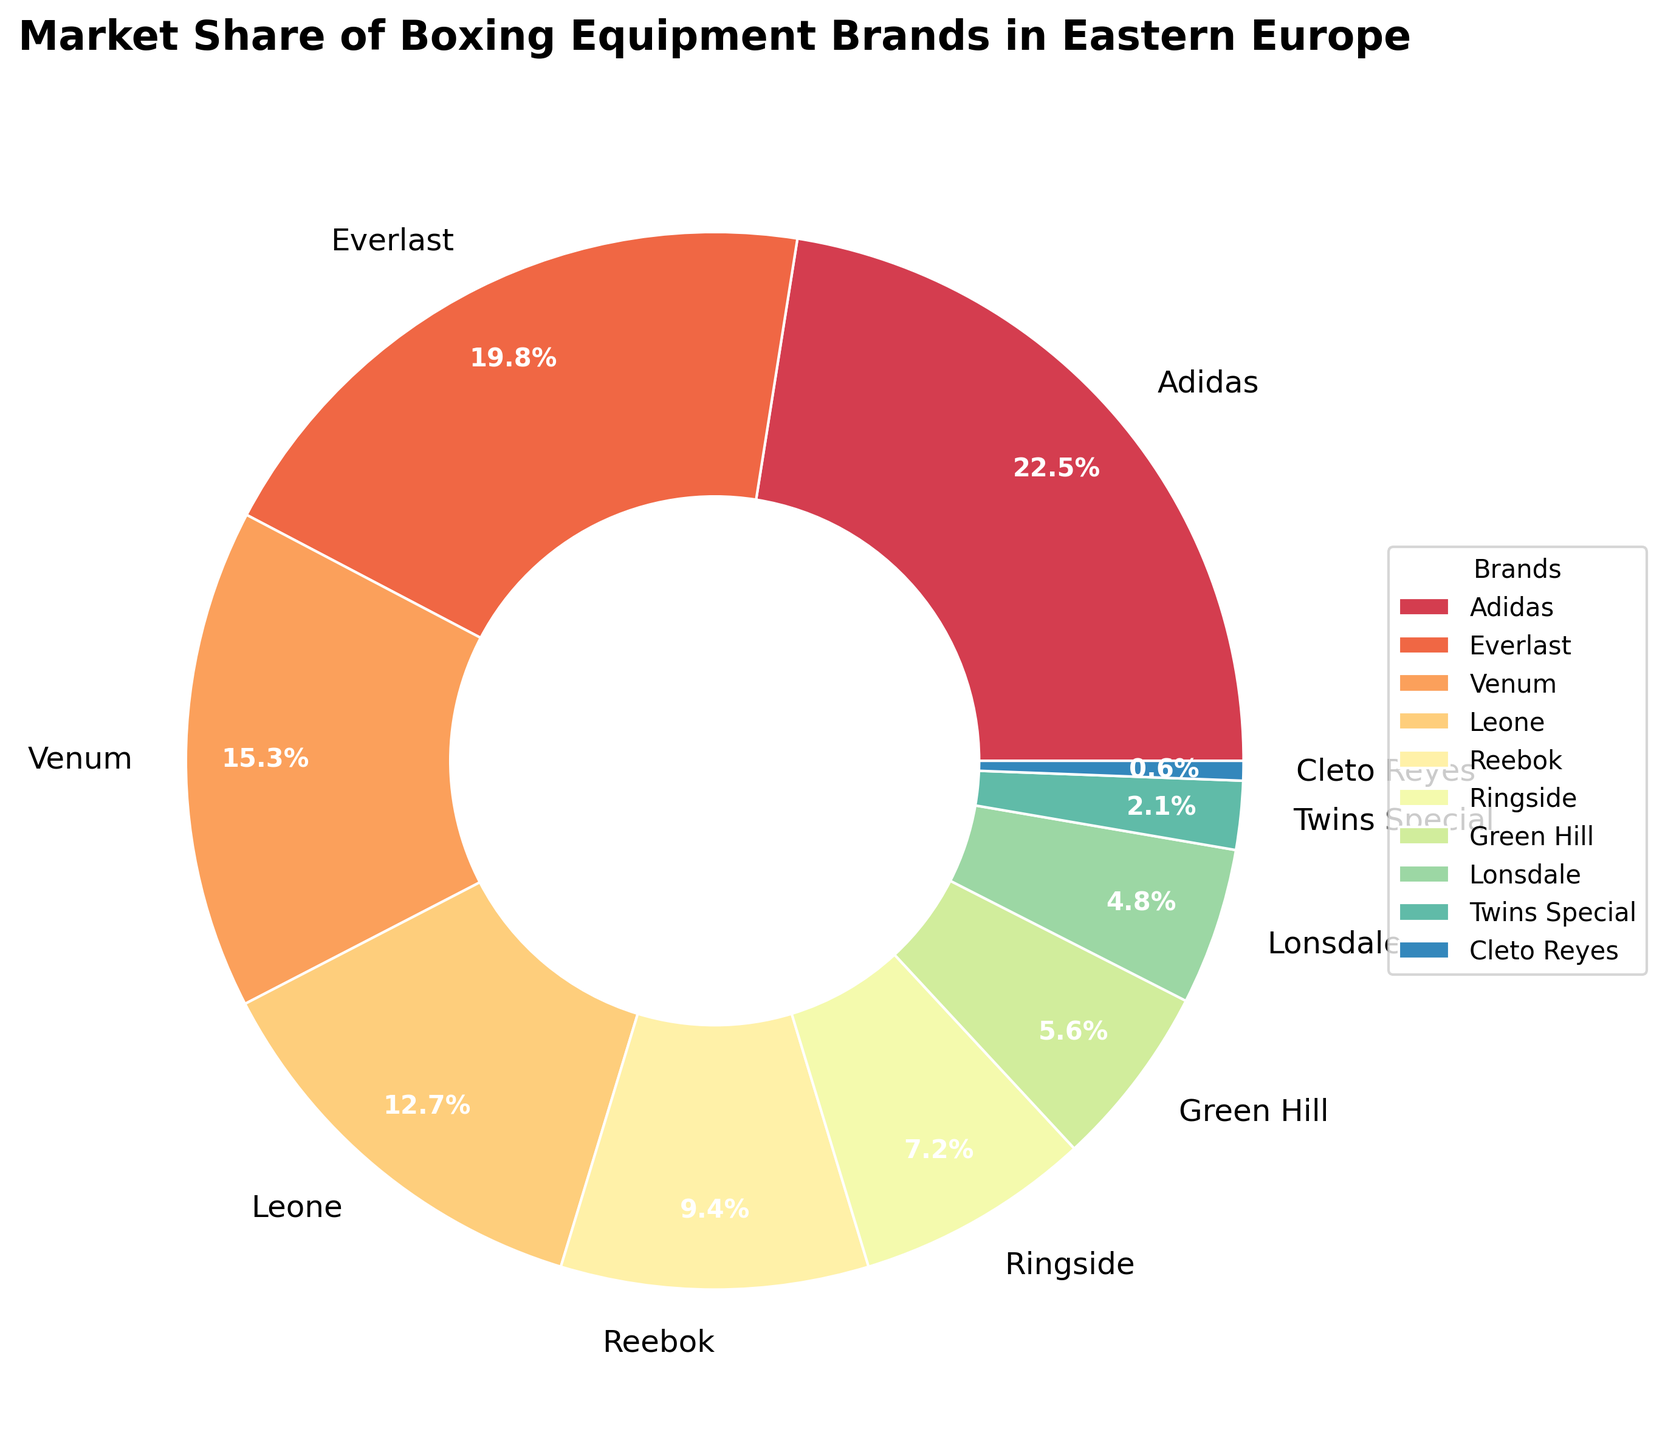Which brand has the highest market share? Adidas has the highest value at 22.5%. This can be identified visually as it occupies the largest portion of the pie chart.
Answer: Adidas What is the combined market share of the top three brands? The top three brands are Adidas (22.5%), Everlast (19.8%), and Venum (15.3%). Adding these together: 22.5 + 19.8 + 15.3 = 57.6%.
Answer: 57.6% How much more market share does Adidas have compared to Everlast? Adidas has a market share of 22.5%, whereas Everlast has 19.8%. Subtracting Everlast's share from Adidas's share: 22.5 - 19.8 = 2.7%.
Answer: 2.7% Which brands have a market share of less than 5%? The brands with less than 5% market share are Lonsdale (4.8%), Twins Special (2.1%), and Cleto Reyes (0.6%). This can be identified by observing the smaller sections of the pie chart and checking their labels.
Answer: Lonsdale, Twins Special, Cleto Reyes What percentage of the market is held by Leone and Reebok combined? Leone has a market share of 12.7% and Reebok has 9.4%. Adding these together: 12.7 + 9.4 = 22.1%.
Answer: 22.1% Which brand occupies the smallest portion of the pie chart? Cleto Reyes occupies the smallest portion with a market share of 0.6%. This can be identified by finding the smallest segment visually.
Answer: Cleto Reyes Is the market share of Venum greater than the combined market share of Ringside and Green Hill? Venum has 15.3%. Ringside has 7.2% and Green Hill has 5.6%, and their combined share is 7.2 + 5.6 = 12.8%. Since 15.3% is greater than 12.8%, Venum's share is greater.
Answer: Yes If Lonsdale's market share doubled, would it surpass Reebok's market share? Lonsdale's market share is 4.8%. If it doubled, it would be 4.8 * 2 = 9.6%. Reebok's market share is 9.4%. Since 9.6% is greater than 9.4%, it would surpass Reebok's share.
Answer: Yes 